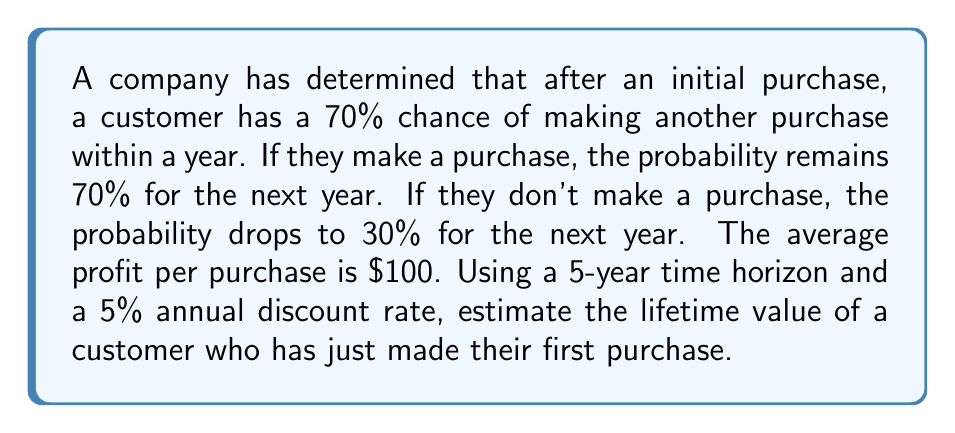What is the answer to this math problem? Let's approach this step-by-step:

1) First, let's calculate the probability of a customer making a purchase in each year:

   Year 1: 100% (initial purchase)
   Year 2: 70%
   Year 3: $0.7 * 0.7 + 0.3 * 0.3 = 0.58$
   Year 4: $0.58 * 0.7 + 0.42 * 0.3 = 0.532$
   Year 5: $0.532 * 0.7 + 0.468 * 0.3 = 0.5132$

2) Now, let's calculate the expected value for each year:

   Year 1: $100 * 1 = $100$
   Year 2: $100 * 0.7 = $70$
   Year 3: $100 * 0.58 = $58$
   Year 4: $100 * 0.532 = $53.20$
   Year 5: $100 * 0.5132 = $51.32$

3) We need to apply the discount factor to each year's expected value. The discount factor for year $n$ is $\frac{1}{(1+r)^n}$, where $r$ is the annual discount rate (5% or 0.05 in this case).

   Year 1: $100 * \frac{1}{(1.05)^1} = $95.24$
   Year 2: $70 * \frac{1}{(1.05)^2} = $63.49$
   Year 3: $58 * \frac{1}{(1.05)^3} = $50.12$
   Year 4: $53.20 * \frac{1}{(1.05)^4} = $43.72$
   Year 5: $51.32 * \frac{1}{(1.05)^5} = $40.20$

4) The lifetime value is the sum of these discounted values:

   $LTV = 95.24 + 63.49 + 50.12 + 43.72 + 40.20 = $292.77$

Therefore, the estimated lifetime value of the customer over a 5-year period is $292.77.
Answer: $292.77 